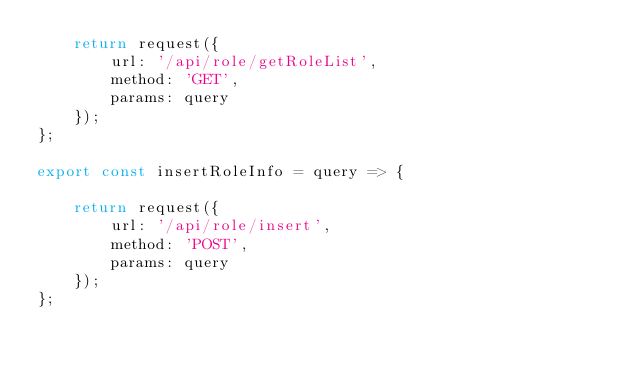<code> <loc_0><loc_0><loc_500><loc_500><_JavaScript_>    return request({
        url: '/api/role/getRoleList',
        method: 'GET',
        params: query 
    });
}; 

export const insertRoleInfo = query => {
    
    return request({
        url: '/api/role/insert',
        method: 'POST',
        params: query 
    });
}; </code> 